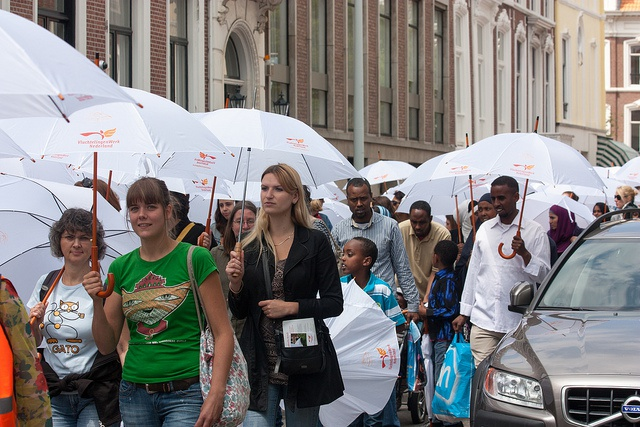Describe the objects in this image and their specific colors. I can see car in gray, darkgray, black, and lightgray tones, people in gray, darkgreen, black, and brown tones, people in gray, black, and maroon tones, people in gray, black, lightgray, and darkgray tones, and umbrella in gray, lavender, lightgray, and darkgray tones in this image. 